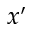Convert formula to latex. <formula><loc_0><loc_0><loc_500><loc_500>x ^ { \prime }</formula> 